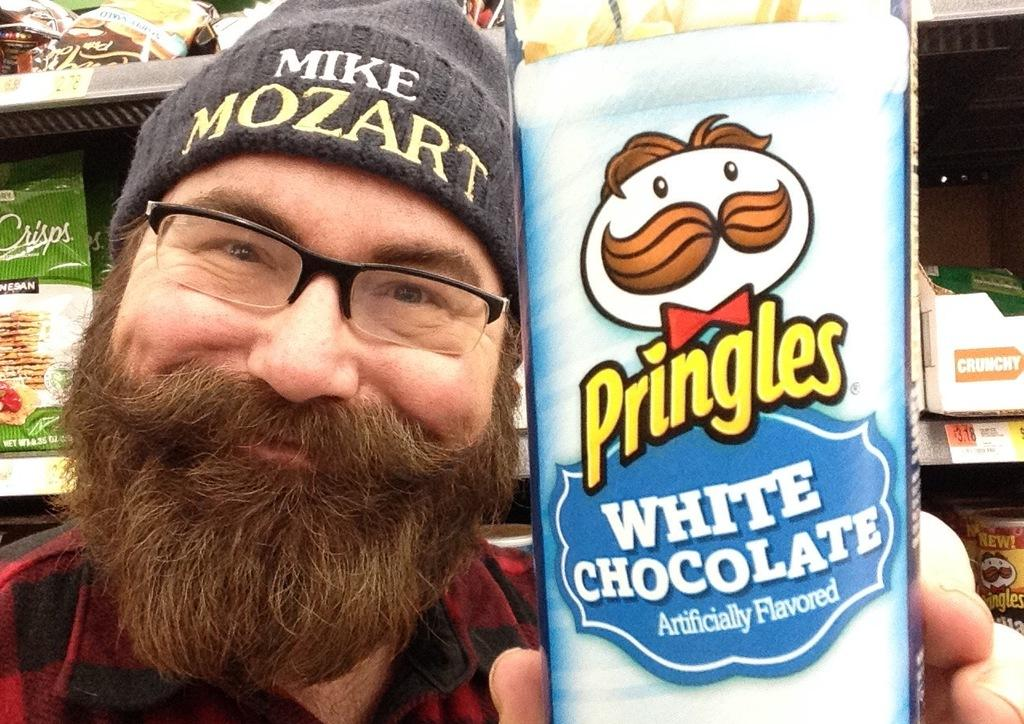Who is in the image? There is a person in the image. What is the person holding? The person is holding a packet. What can be seen in the background of the image? There are shelves in the background of the image. What else is present on the shelves? Packets are present on the shelves in the background. How many baby bread boats can be seen in the image? There are no baby bread boats present in the image. 